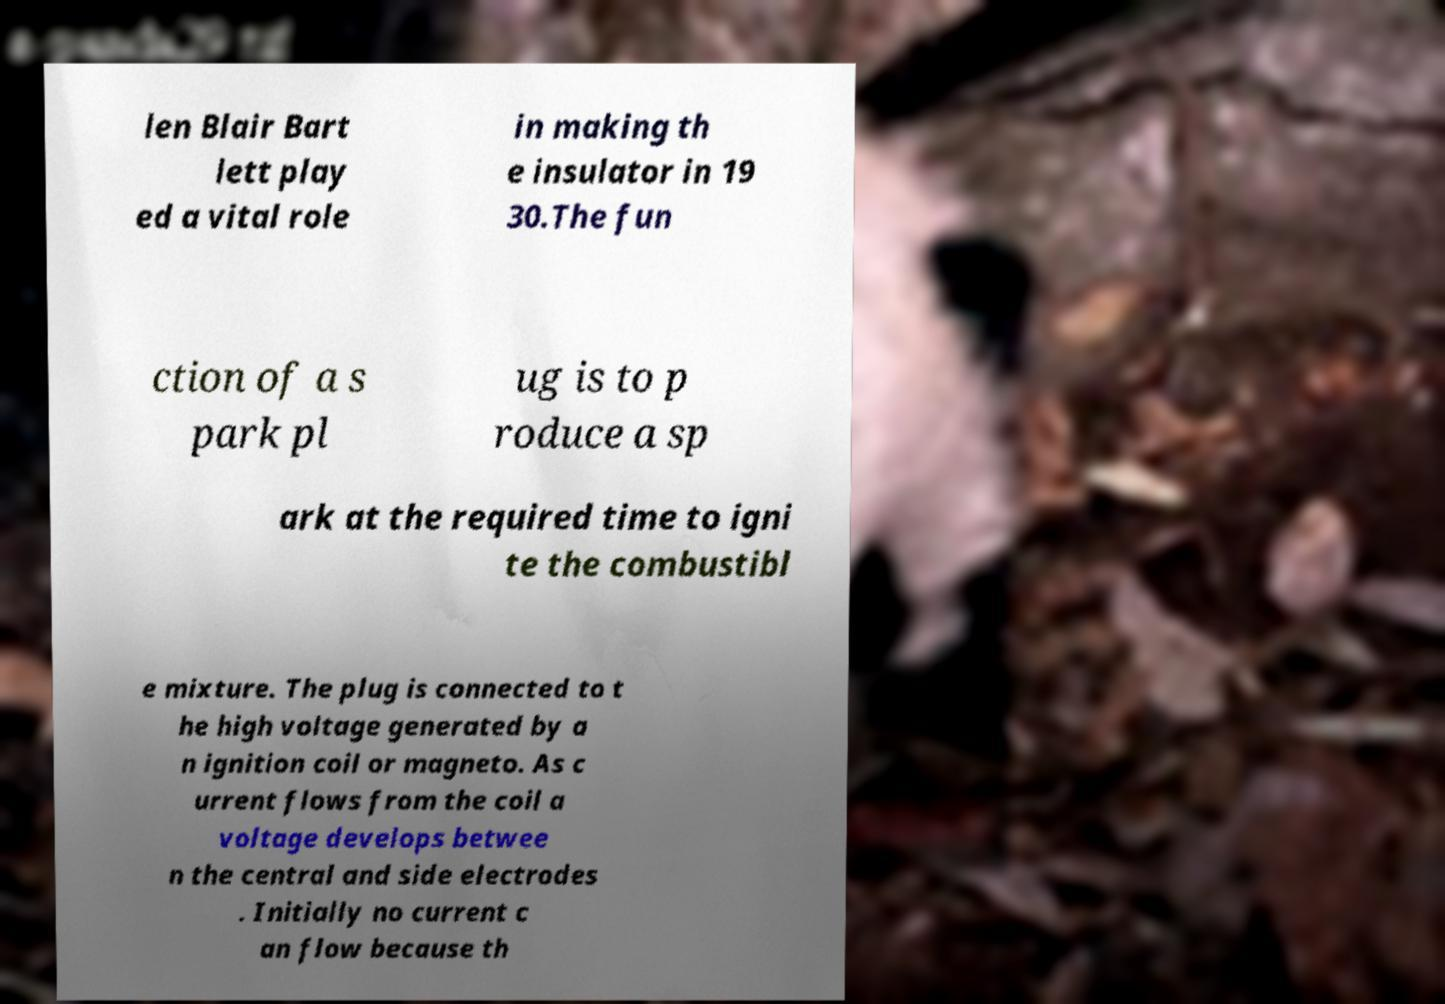What messages or text are displayed in this image? I need them in a readable, typed format. len Blair Bart lett play ed a vital role in making th e insulator in 19 30.The fun ction of a s park pl ug is to p roduce a sp ark at the required time to igni te the combustibl e mixture. The plug is connected to t he high voltage generated by a n ignition coil or magneto. As c urrent flows from the coil a voltage develops betwee n the central and side electrodes . Initially no current c an flow because th 